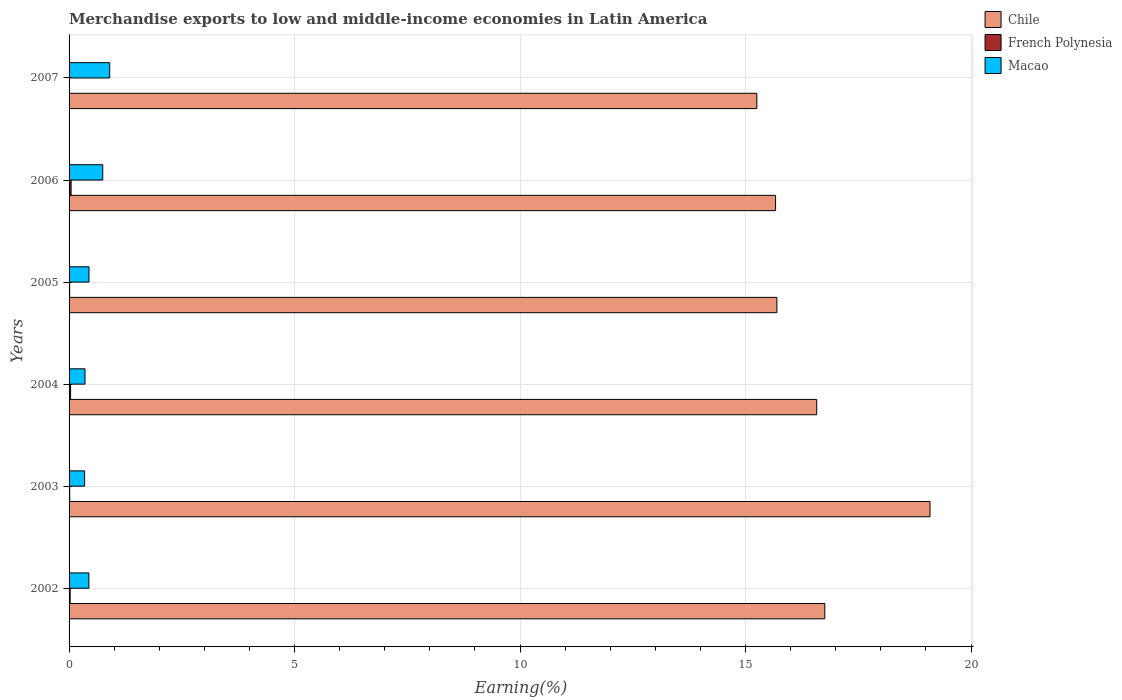How many different coloured bars are there?
Your answer should be very brief. 3. How many groups of bars are there?
Offer a very short reply. 6. How many bars are there on the 6th tick from the top?
Ensure brevity in your answer.  3. What is the label of the 2nd group of bars from the top?
Ensure brevity in your answer.  2006. In how many cases, is the number of bars for a given year not equal to the number of legend labels?
Your answer should be very brief. 0. What is the percentage of amount earned from merchandise exports in Chile in 2002?
Your answer should be very brief. 16.76. Across all years, what is the maximum percentage of amount earned from merchandise exports in Chile?
Provide a succinct answer. 19.09. Across all years, what is the minimum percentage of amount earned from merchandise exports in Macao?
Keep it short and to the point. 0.34. In which year was the percentage of amount earned from merchandise exports in Macao minimum?
Make the answer very short. 2003. What is the total percentage of amount earned from merchandise exports in Chile in the graph?
Your answer should be compact. 99.04. What is the difference between the percentage of amount earned from merchandise exports in Chile in 2002 and that in 2005?
Offer a very short reply. 1.06. What is the difference between the percentage of amount earned from merchandise exports in Chile in 2003 and the percentage of amount earned from merchandise exports in Macao in 2002?
Provide a succinct answer. 18.65. What is the average percentage of amount earned from merchandise exports in Macao per year?
Your answer should be compact. 0.54. In the year 2004, what is the difference between the percentage of amount earned from merchandise exports in French Polynesia and percentage of amount earned from merchandise exports in Macao?
Your response must be concise. -0.32. In how many years, is the percentage of amount earned from merchandise exports in French Polynesia greater than 9 %?
Your answer should be very brief. 0. What is the ratio of the percentage of amount earned from merchandise exports in Macao in 2003 to that in 2004?
Your response must be concise. 0.97. Is the percentage of amount earned from merchandise exports in Macao in 2005 less than that in 2006?
Give a very brief answer. Yes. Is the difference between the percentage of amount earned from merchandise exports in French Polynesia in 2002 and 2004 greater than the difference between the percentage of amount earned from merchandise exports in Macao in 2002 and 2004?
Offer a very short reply. No. What is the difference between the highest and the second highest percentage of amount earned from merchandise exports in Macao?
Keep it short and to the point. 0.15. What is the difference between the highest and the lowest percentage of amount earned from merchandise exports in Macao?
Offer a terse response. 0.56. In how many years, is the percentage of amount earned from merchandise exports in French Polynesia greater than the average percentage of amount earned from merchandise exports in French Polynesia taken over all years?
Ensure brevity in your answer.  3. Is the sum of the percentage of amount earned from merchandise exports in Chile in 2002 and 2003 greater than the maximum percentage of amount earned from merchandise exports in French Polynesia across all years?
Provide a succinct answer. Yes. What does the 3rd bar from the bottom in 2006 represents?
Provide a succinct answer. Macao. How many bars are there?
Provide a short and direct response. 18. Are all the bars in the graph horizontal?
Make the answer very short. Yes. How many years are there in the graph?
Provide a short and direct response. 6. What is the difference between two consecutive major ticks on the X-axis?
Make the answer very short. 5. Are the values on the major ticks of X-axis written in scientific E-notation?
Keep it short and to the point. No. Does the graph contain grids?
Your answer should be compact. Yes. How many legend labels are there?
Offer a terse response. 3. How are the legend labels stacked?
Make the answer very short. Vertical. What is the title of the graph?
Provide a short and direct response. Merchandise exports to low and middle-income economies in Latin America. What is the label or title of the X-axis?
Offer a terse response. Earning(%). What is the label or title of the Y-axis?
Provide a short and direct response. Years. What is the Earning(%) in Chile in 2002?
Ensure brevity in your answer.  16.76. What is the Earning(%) of French Polynesia in 2002?
Keep it short and to the point. 0.02. What is the Earning(%) of Macao in 2002?
Provide a short and direct response. 0.44. What is the Earning(%) of Chile in 2003?
Your answer should be compact. 19.09. What is the Earning(%) of French Polynesia in 2003?
Offer a very short reply. 0.01. What is the Earning(%) of Macao in 2003?
Make the answer very short. 0.34. What is the Earning(%) of Chile in 2004?
Your response must be concise. 16.58. What is the Earning(%) of French Polynesia in 2004?
Provide a succinct answer. 0.03. What is the Earning(%) in Macao in 2004?
Offer a terse response. 0.35. What is the Earning(%) in Chile in 2005?
Make the answer very short. 15.7. What is the Earning(%) of French Polynesia in 2005?
Provide a short and direct response. 0.01. What is the Earning(%) in Macao in 2005?
Provide a short and direct response. 0.44. What is the Earning(%) of Chile in 2006?
Offer a terse response. 15.67. What is the Earning(%) of French Polynesia in 2006?
Give a very brief answer. 0.05. What is the Earning(%) in Macao in 2006?
Your answer should be compact. 0.75. What is the Earning(%) of Chile in 2007?
Your response must be concise. 15.25. What is the Earning(%) in French Polynesia in 2007?
Give a very brief answer. 0. What is the Earning(%) in Macao in 2007?
Provide a short and direct response. 0.9. Across all years, what is the maximum Earning(%) of Chile?
Your answer should be compact. 19.09. Across all years, what is the maximum Earning(%) of French Polynesia?
Provide a succinct answer. 0.05. Across all years, what is the maximum Earning(%) in Macao?
Provide a succinct answer. 0.9. Across all years, what is the minimum Earning(%) of Chile?
Offer a very short reply. 15.25. Across all years, what is the minimum Earning(%) in French Polynesia?
Offer a very short reply. 0. Across all years, what is the minimum Earning(%) of Macao?
Provide a short and direct response. 0.34. What is the total Earning(%) in Chile in the graph?
Offer a terse response. 99.04. What is the total Earning(%) in French Polynesia in the graph?
Offer a terse response. 0.13. What is the total Earning(%) in Macao in the graph?
Give a very brief answer. 3.23. What is the difference between the Earning(%) in Chile in 2002 and that in 2003?
Your answer should be compact. -2.33. What is the difference between the Earning(%) of French Polynesia in 2002 and that in 2003?
Ensure brevity in your answer.  0.01. What is the difference between the Earning(%) in Macao in 2002 and that in 2003?
Your answer should be compact. 0.09. What is the difference between the Earning(%) in Chile in 2002 and that in 2004?
Your answer should be very brief. 0.18. What is the difference between the Earning(%) in French Polynesia in 2002 and that in 2004?
Offer a very short reply. -0.01. What is the difference between the Earning(%) in Macao in 2002 and that in 2004?
Your answer should be very brief. 0.09. What is the difference between the Earning(%) in Chile in 2002 and that in 2005?
Your answer should be compact. 1.06. What is the difference between the Earning(%) of French Polynesia in 2002 and that in 2005?
Make the answer very short. 0.01. What is the difference between the Earning(%) in Macao in 2002 and that in 2005?
Your answer should be compact. -0. What is the difference between the Earning(%) in Chile in 2002 and that in 2006?
Your response must be concise. 1.09. What is the difference between the Earning(%) in French Polynesia in 2002 and that in 2006?
Ensure brevity in your answer.  -0.02. What is the difference between the Earning(%) of Macao in 2002 and that in 2006?
Your answer should be compact. -0.31. What is the difference between the Earning(%) in Chile in 2002 and that in 2007?
Your answer should be very brief. 1.51. What is the difference between the Earning(%) of French Polynesia in 2002 and that in 2007?
Your response must be concise. 0.02. What is the difference between the Earning(%) of Macao in 2002 and that in 2007?
Make the answer very short. -0.46. What is the difference between the Earning(%) of Chile in 2003 and that in 2004?
Offer a terse response. 2.51. What is the difference between the Earning(%) in French Polynesia in 2003 and that in 2004?
Ensure brevity in your answer.  -0.02. What is the difference between the Earning(%) of Macao in 2003 and that in 2004?
Your answer should be compact. -0.01. What is the difference between the Earning(%) of Chile in 2003 and that in 2005?
Ensure brevity in your answer.  3.4. What is the difference between the Earning(%) in French Polynesia in 2003 and that in 2005?
Offer a very short reply. 0. What is the difference between the Earning(%) in Macao in 2003 and that in 2005?
Provide a short and direct response. -0.1. What is the difference between the Earning(%) of Chile in 2003 and that in 2006?
Make the answer very short. 3.42. What is the difference between the Earning(%) in French Polynesia in 2003 and that in 2006?
Provide a succinct answer. -0.03. What is the difference between the Earning(%) in Macao in 2003 and that in 2006?
Your answer should be very brief. -0.4. What is the difference between the Earning(%) of Chile in 2003 and that in 2007?
Offer a very short reply. 3.84. What is the difference between the Earning(%) in French Polynesia in 2003 and that in 2007?
Your answer should be very brief. 0.01. What is the difference between the Earning(%) in Macao in 2003 and that in 2007?
Provide a succinct answer. -0.56. What is the difference between the Earning(%) in Chile in 2004 and that in 2005?
Give a very brief answer. 0.88. What is the difference between the Earning(%) of French Polynesia in 2004 and that in 2005?
Keep it short and to the point. 0.02. What is the difference between the Earning(%) of Macao in 2004 and that in 2005?
Ensure brevity in your answer.  -0.09. What is the difference between the Earning(%) of Chile in 2004 and that in 2006?
Your answer should be very brief. 0.91. What is the difference between the Earning(%) in French Polynesia in 2004 and that in 2006?
Provide a short and direct response. -0.01. What is the difference between the Earning(%) in Macao in 2004 and that in 2006?
Keep it short and to the point. -0.39. What is the difference between the Earning(%) in Chile in 2004 and that in 2007?
Give a very brief answer. 1.33. What is the difference between the Earning(%) in French Polynesia in 2004 and that in 2007?
Provide a short and direct response. 0.03. What is the difference between the Earning(%) of Macao in 2004 and that in 2007?
Give a very brief answer. -0.55. What is the difference between the Earning(%) in Chile in 2005 and that in 2006?
Provide a short and direct response. 0.03. What is the difference between the Earning(%) of French Polynesia in 2005 and that in 2006?
Offer a very short reply. -0.03. What is the difference between the Earning(%) of Macao in 2005 and that in 2006?
Your answer should be compact. -0.31. What is the difference between the Earning(%) of Chile in 2005 and that in 2007?
Give a very brief answer. 0.45. What is the difference between the Earning(%) of French Polynesia in 2005 and that in 2007?
Provide a short and direct response. 0.01. What is the difference between the Earning(%) of Macao in 2005 and that in 2007?
Your answer should be very brief. -0.46. What is the difference between the Earning(%) in Chile in 2006 and that in 2007?
Your response must be concise. 0.42. What is the difference between the Earning(%) in French Polynesia in 2006 and that in 2007?
Your answer should be compact. 0.04. What is the difference between the Earning(%) in Macao in 2006 and that in 2007?
Your answer should be very brief. -0.15. What is the difference between the Earning(%) of Chile in 2002 and the Earning(%) of French Polynesia in 2003?
Give a very brief answer. 16.74. What is the difference between the Earning(%) in Chile in 2002 and the Earning(%) in Macao in 2003?
Make the answer very short. 16.41. What is the difference between the Earning(%) of French Polynesia in 2002 and the Earning(%) of Macao in 2003?
Provide a short and direct response. -0.32. What is the difference between the Earning(%) in Chile in 2002 and the Earning(%) in French Polynesia in 2004?
Give a very brief answer. 16.72. What is the difference between the Earning(%) in Chile in 2002 and the Earning(%) in Macao in 2004?
Provide a succinct answer. 16.41. What is the difference between the Earning(%) of French Polynesia in 2002 and the Earning(%) of Macao in 2004?
Offer a terse response. -0.33. What is the difference between the Earning(%) in Chile in 2002 and the Earning(%) in French Polynesia in 2005?
Provide a short and direct response. 16.75. What is the difference between the Earning(%) in Chile in 2002 and the Earning(%) in Macao in 2005?
Make the answer very short. 16.32. What is the difference between the Earning(%) in French Polynesia in 2002 and the Earning(%) in Macao in 2005?
Provide a short and direct response. -0.42. What is the difference between the Earning(%) in Chile in 2002 and the Earning(%) in French Polynesia in 2006?
Ensure brevity in your answer.  16.71. What is the difference between the Earning(%) of Chile in 2002 and the Earning(%) of Macao in 2006?
Ensure brevity in your answer.  16.01. What is the difference between the Earning(%) in French Polynesia in 2002 and the Earning(%) in Macao in 2006?
Your answer should be very brief. -0.72. What is the difference between the Earning(%) in Chile in 2002 and the Earning(%) in French Polynesia in 2007?
Your answer should be compact. 16.76. What is the difference between the Earning(%) of Chile in 2002 and the Earning(%) of Macao in 2007?
Make the answer very short. 15.86. What is the difference between the Earning(%) in French Polynesia in 2002 and the Earning(%) in Macao in 2007?
Your answer should be very brief. -0.88. What is the difference between the Earning(%) in Chile in 2003 and the Earning(%) in French Polynesia in 2004?
Keep it short and to the point. 19.06. What is the difference between the Earning(%) of Chile in 2003 and the Earning(%) of Macao in 2004?
Ensure brevity in your answer.  18.74. What is the difference between the Earning(%) of French Polynesia in 2003 and the Earning(%) of Macao in 2004?
Your answer should be very brief. -0.34. What is the difference between the Earning(%) in Chile in 2003 and the Earning(%) in French Polynesia in 2005?
Give a very brief answer. 19.08. What is the difference between the Earning(%) of Chile in 2003 and the Earning(%) of Macao in 2005?
Your response must be concise. 18.65. What is the difference between the Earning(%) in French Polynesia in 2003 and the Earning(%) in Macao in 2005?
Your answer should be very brief. -0.43. What is the difference between the Earning(%) of Chile in 2003 and the Earning(%) of French Polynesia in 2006?
Make the answer very short. 19.05. What is the difference between the Earning(%) in Chile in 2003 and the Earning(%) in Macao in 2006?
Make the answer very short. 18.34. What is the difference between the Earning(%) of French Polynesia in 2003 and the Earning(%) of Macao in 2006?
Offer a very short reply. -0.73. What is the difference between the Earning(%) in Chile in 2003 and the Earning(%) in French Polynesia in 2007?
Provide a short and direct response. 19.09. What is the difference between the Earning(%) of Chile in 2003 and the Earning(%) of Macao in 2007?
Provide a short and direct response. 18.19. What is the difference between the Earning(%) of French Polynesia in 2003 and the Earning(%) of Macao in 2007?
Offer a terse response. -0.89. What is the difference between the Earning(%) of Chile in 2004 and the Earning(%) of French Polynesia in 2005?
Provide a succinct answer. 16.57. What is the difference between the Earning(%) of Chile in 2004 and the Earning(%) of Macao in 2005?
Provide a short and direct response. 16.14. What is the difference between the Earning(%) of French Polynesia in 2004 and the Earning(%) of Macao in 2005?
Provide a short and direct response. -0.41. What is the difference between the Earning(%) in Chile in 2004 and the Earning(%) in French Polynesia in 2006?
Ensure brevity in your answer.  16.53. What is the difference between the Earning(%) in Chile in 2004 and the Earning(%) in Macao in 2006?
Keep it short and to the point. 15.83. What is the difference between the Earning(%) of French Polynesia in 2004 and the Earning(%) of Macao in 2006?
Make the answer very short. -0.71. What is the difference between the Earning(%) of Chile in 2004 and the Earning(%) of French Polynesia in 2007?
Your response must be concise. 16.58. What is the difference between the Earning(%) in Chile in 2004 and the Earning(%) in Macao in 2007?
Your answer should be very brief. 15.68. What is the difference between the Earning(%) in French Polynesia in 2004 and the Earning(%) in Macao in 2007?
Your response must be concise. -0.87. What is the difference between the Earning(%) in Chile in 2005 and the Earning(%) in French Polynesia in 2006?
Make the answer very short. 15.65. What is the difference between the Earning(%) in Chile in 2005 and the Earning(%) in Macao in 2006?
Make the answer very short. 14.95. What is the difference between the Earning(%) in French Polynesia in 2005 and the Earning(%) in Macao in 2006?
Provide a short and direct response. -0.73. What is the difference between the Earning(%) in Chile in 2005 and the Earning(%) in French Polynesia in 2007?
Provide a succinct answer. 15.69. What is the difference between the Earning(%) in Chile in 2005 and the Earning(%) in Macao in 2007?
Your answer should be compact. 14.8. What is the difference between the Earning(%) of French Polynesia in 2005 and the Earning(%) of Macao in 2007?
Your response must be concise. -0.89. What is the difference between the Earning(%) in Chile in 2006 and the Earning(%) in French Polynesia in 2007?
Your answer should be very brief. 15.67. What is the difference between the Earning(%) of Chile in 2006 and the Earning(%) of Macao in 2007?
Make the answer very short. 14.77. What is the difference between the Earning(%) of French Polynesia in 2006 and the Earning(%) of Macao in 2007?
Give a very brief answer. -0.86. What is the average Earning(%) in Chile per year?
Make the answer very short. 16.51. What is the average Earning(%) in French Polynesia per year?
Offer a very short reply. 0.02. What is the average Earning(%) in Macao per year?
Make the answer very short. 0.54. In the year 2002, what is the difference between the Earning(%) in Chile and Earning(%) in French Polynesia?
Give a very brief answer. 16.73. In the year 2002, what is the difference between the Earning(%) of Chile and Earning(%) of Macao?
Ensure brevity in your answer.  16.32. In the year 2002, what is the difference between the Earning(%) in French Polynesia and Earning(%) in Macao?
Your answer should be compact. -0.42. In the year 2003, what is the difference between the Earning(%) in Chile and Earning(%) in French Polynesia?
Make the answer very short. 19.08. In the year 2003, what is the difference between the Earning(%) of Chile and Earning(%) of Macao?
Make the answer very short. 18.75. In the year 2003, what is the difference between the Earning(%) of French Polynesia and Earning(%) of Macao?
Your answer should be compact. -0.33. In the year 2004, what is the difference between the Earning(%) of Chile and Earning(%) of French Polynesia?
Keep it short and to the point. 16.55. In the year 2004, what is the difference between the Earning(%) of Chile and Earning(%) of Macao?
Your answer should be very brief. 16.23. In the year 2004, what is the difference between the Earning(%) in French Polynesia and Earning(%) in Macao?
Ensure brevity in your answer.  -0.32. In the year 2005, what is the difference between the Earning(%) of Chile and Earning(%) of French Polynesia?
Your answer should be compact. 15.68. In the year 2005, what is the difference between the Earning(%) of Chile and Earning(%) of Macao?
Ensure brevity in your answer.  15.25. In the year 2005, what is the difference between the Earning(%) in French Polynesia and Earning(%) in Macao?
Offer a very short reply. -0.43. In the year 2006, what is the difference between the Earning(%) in Chile and Earning(%) in French Polynesia?
Ensure brevity in your answer.  15.62. In the year 2006, what is the difference between the Earning(%) of Chile and Earning(%) of Macao?
Provide a short and direct response. 14.92. In the year 2006, what is the difference between the Earning(%) of French Polynesia and Earning(%) of Macao?
Ensure brevity in your answer.  -0.7. In the year 2007, what is the difference between the Earning(%) in Chile and Earning(%) in French Polynesia?
Keep it short and to the point. 15.25. In the year 2007, what is the difference between the Earning(%) of Chile and Earning(%) of Macao?
Provide a succinct answer. 14.35. In the year 2007, what is the difference between the Earning(%) of French Polynesia and Earning(%) of Macao?
Offer a terse response. -0.9. What is the ratio of the Earning(%) of Chile in 2002 to that in 2003?
Your response must be concise. 0.88. What is the ratio of the Earning(%) of French Polynesia in 2002 to that in 2003?
Make the answer very short. 1.67. What is the ratio of the Earning(%) of Macao in 2002 to that in 2003?
Make the answer very short. 1.27. What is the ratio of the Earning(%) of Chile in 2002 to that in 2004?
Provide a succinct answer. 1.01. What is the ratio of the Earning(%) of French Polynesia in 2002 to that in 2004?
Your response must be concise. 0.71. What is the ratio of the Earning(%) of Macao in 2002 to that in 2004?
Keep it short and to the point. 1.24. What is the ratio of the Earning(%) in Chile in 2002 to that in 2005?
Your answer should be compact. 1.07. What is the ratio of the Earning(%) in French Polynesia in 2002 to that in 2005?
Provide a succinct answer. 1.79. What is the ratio of the Earning(%) in Macao in 2002 to that in 2005?
Ensure brevity in your answer.  0.99. What is the ratio of the Earning(%) in Chile in 2002 to that in 2006?
Keep it short and to the point. 1.07. What is the ratio of the Earning(%) of French Polynesia in 2002 to that in 2006?
Offer a terse response. 0.53. What is the ratio of the Earning(%) in Macao in 2002 to that in 2006?
Make the answer very short. 0.59. What is the ratio of the Earning(%) in Chile in 2002 to that in 2007?
Make the answer very short. 1.1. What is the ratio of the Earning(%) of French Polynesia in 2002 to that in 2007?
Give a very brief answer. 17.77. What is the ratio of the Earning(%) of Macao in 2002 to that in 2007?
Provide a succinct answer. 0.49. What is the ratio of the Earning(%) of Chile in 2003 to that in 2004?
Offer a very short reply. 1.15. What is the ratio of the Earning(%) in French Polynesia in 2003 to that in 2004?
Give a very brief answer. 0.42. What is the ratio of the Earning(%) of Macao in 2003 to that in 2004?
Offer a very short reply. 0.97. What is the ratio of the Earning(%) in Chile in 2003 to that in 2005?
Offer a very short reply. 1.22. What is the ratio of the Earning(%) of French Polynesia in 2003 to that in 2005?
Your answer should be very brief. 1.07. What is the ratio of the Earning(%) in Macao in 2003 to that in 2005?
Ensure brevity in your answer.  0.78. What is the ratio of the Earning(%) in Chile in 2003 to that in 2006?
Your answer should be compact. 1.22. What is the ratio of the Earning(%) in French Polynesia in 2003 to that in 2006?
Keep it short and to the point. 0.32. What is the ratio of the Earning(%) of Macao in 2003 to that in 2006?
Provide a short and direct response. 0.46. What is the ratio of the Earning(%) of Chile in 2003 to that in 2007?
Your answer should be very brief. 1.25. What is the ratio of the Earning(%) in French Polynesia in 2003 to that in 2007?
Make the answer very short. 10.61. What is the ratio of the Earning(%) in Macao in 2003 to that in 2007?
Ensure brevity in your answer.  0.38. What is the ratio of the Earning(%) of Chile in 2004 to that in 2005?
Ensure brevity in your answer.  1.06. What is the ratio of the Earning(%) of French Polynesia in 2004 to that in 2005?
Offer a terse response. 2.51. What is the ratio of the Earning(%) in Macao in 2004 to that in 2005?
Keep it short and to the point. 0.8. What is the ratio of the Earning(%) in Chile in 2004 to that in 2006?
Ensure brevity in your answer.  1.06. What is the ratio of the Earning(%) in French Polynesia in 2004 to that in 2006?
Provide a succinct answer. 0.75. What is the ratio of the Earning(%) of Macao in 2004 to that in 2006?
Make the answer very short. 0.47. What is the ratio of the Earning(%) in Chile in 2004 to that in 2007?
Your answer should be compact. 1.09. What is the ratio of the Earning(%) of French Polynesia in 2004 to that in 2007?
Make the answer very short. 24.97. What is the ratio of the Earning(%) of Macao in 2004 to that in 2007?
Your answer should be compact. 0.39. What is the ratio of the Earning(%) of Chile in 2005 to that in 2006?
Provide a succinct answer. 1. What is the ratio of the Earning(%) in French Polynesia in 2005 to that in 2006?
Give a very brief answer. 0.3. What is the ratio of the Earning(%) of Macao in 2005 to that in 2006?
Provide a short and direct response. 0.59. What is the ratio of the Earning(%) in Chile in 2005 to that in 2007?
Your answer should be compact. 1.03. What is the ratio of the Earning(%) in French Polynesia in 2005 to that in 2007?
Your answer should be compact. 9.95. What is the ratio of the Earning(%) in Macao in 2005 to that in 2007?
Ensure brevity in your answer.  0.49. What is the ratio of the Earning(%) of Chile in 2006 to that in 2007?
Provide a succinct answer. 1.03. What is the ratio of the Earning(%) in French Polynesia in 2006 to that in 2007?
Ensure brevity in your answer.  33.4. What is the ratio of the Earning(%) in Macao in 2006 to that in 2007?
Ensure brevity in your answer.  0.83. What is the difference between the highest and the second highest Earning(%) in Chile?
Make the answer very short. 2.33. What is the difference between the highest and the second highest Earning(%) of French Polynesia?
Keep it short and to the point. 0.01. What is the difference between the highest and the second highest Earning(%) of Macao?
Offer a very short reply. 0.15. What is the difference between the highest and the lowest Earning(%) in Chile?
Offer a very short reply. 3.84. What is the difference between the highest and the lowest Earning(%) in French Polynesia?
Your answer should be very brief. 0.04. What is the difference between the highest and the lowest Earning(%) of Macao?
Provide a short and direct response. 0.56. 